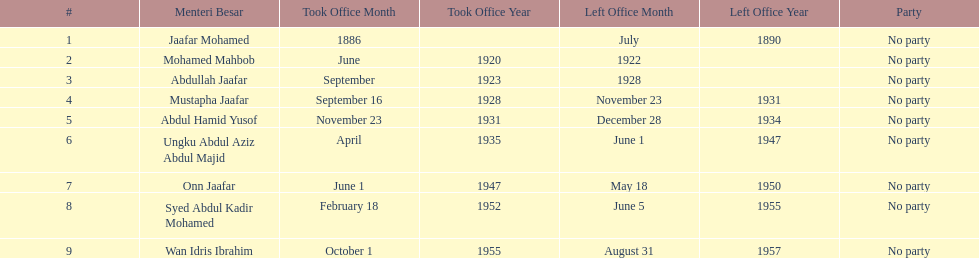Who spend the most amount of time in office? Ungku Abdul Aziz Abdul Majid. 